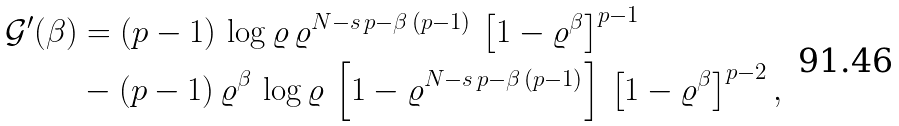Convert formula to latex. <formula><loc_0><loc_0><loc_500><loc_500>\mathcal { G } ^ { \prime } ( \beta ) & = ( p - 1 ) \, \log \varrho \, \varrho ^ { N - s \, p - \beta \, ( p - 1 ) } \, \left [ 1 - \varrho ^ { \beta } \right ] ^ { p - 1 } \\ & - ( p - 1 ) \, \varrho ^ { \beta } \, \log \varrho \, \left [ 1 - \varrho ^ { N - s \, p - \beta \, ( p - 1 ) } \right ] \, \left [ 1 - \varrho ^ { \beta } \right ] ^ { p - 2 } ,</formula> 